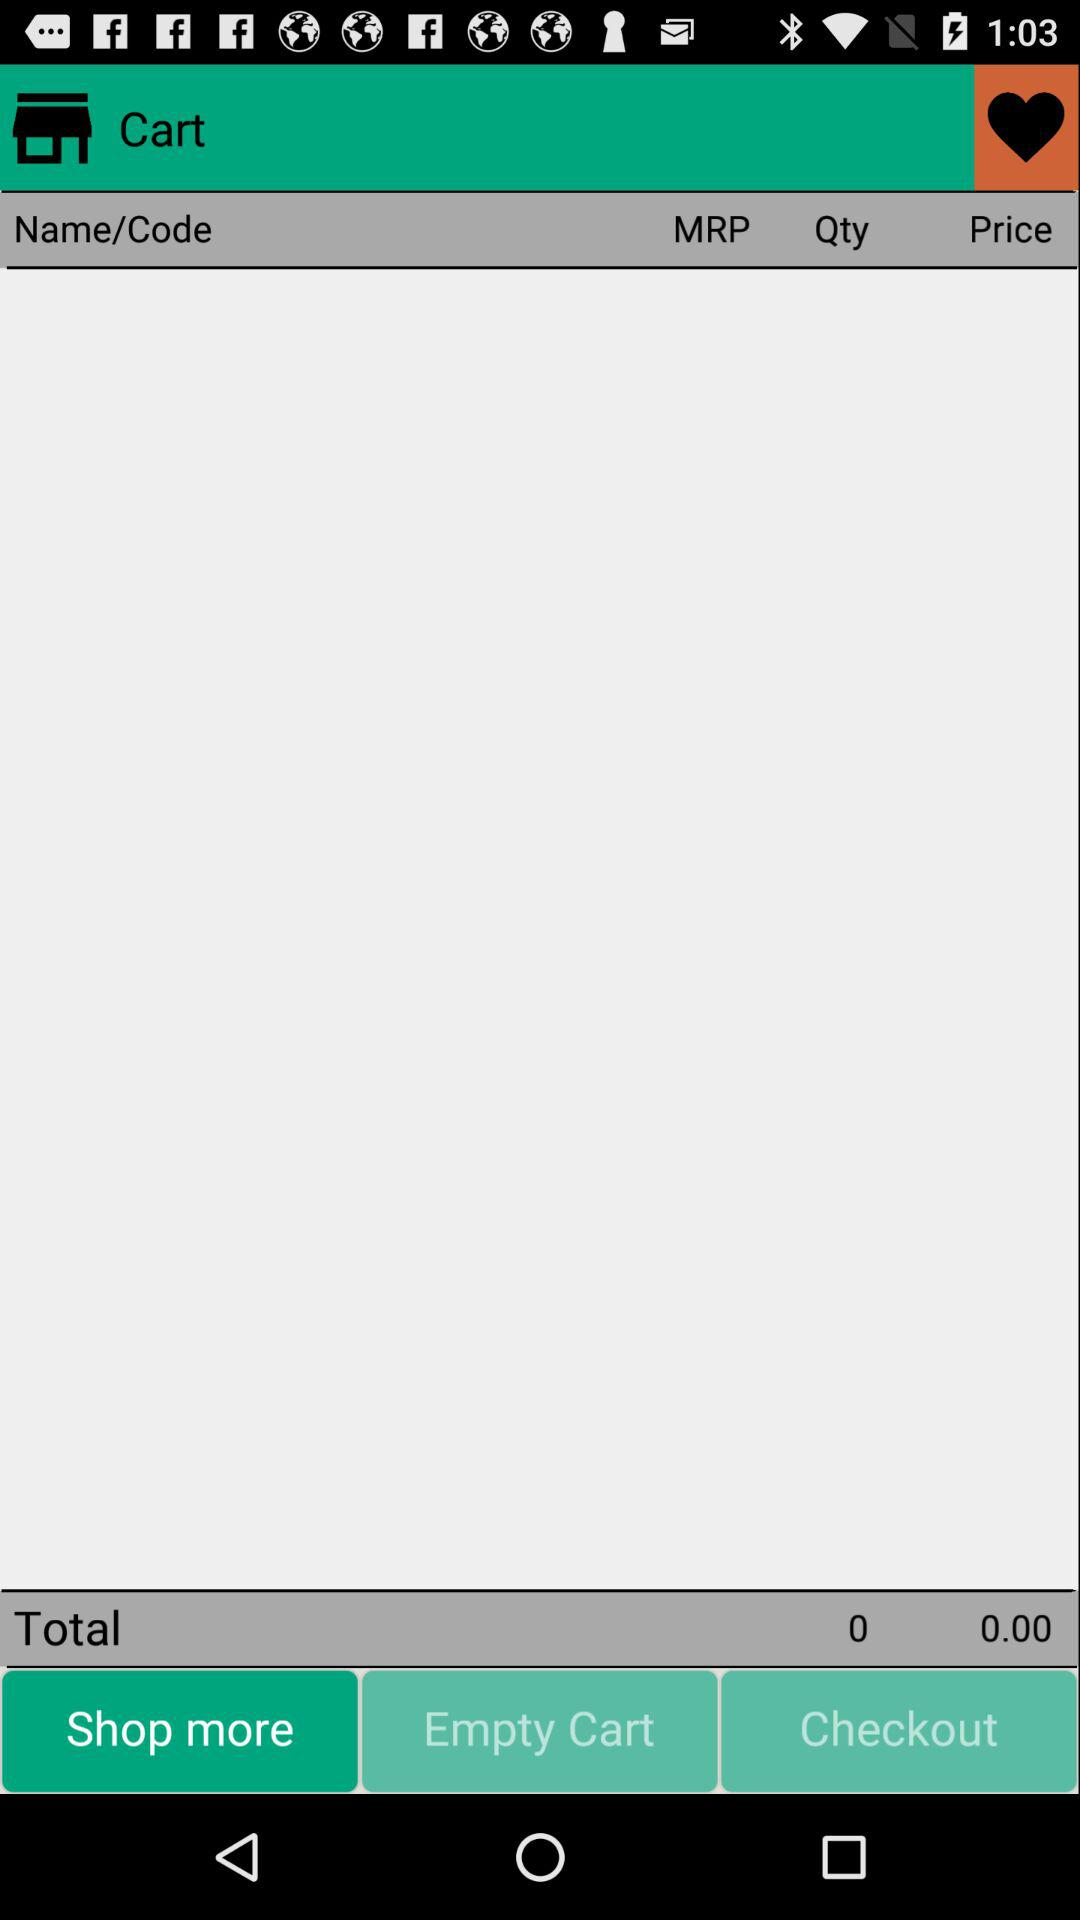How many items are in the cart?
Answer the question using a single word or phrase. 0 